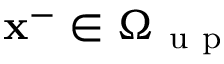<formula> <loc_0><loc_0><loc_500><loc_500>x ^ { - } \in \Omega _ { u p }</formula> 